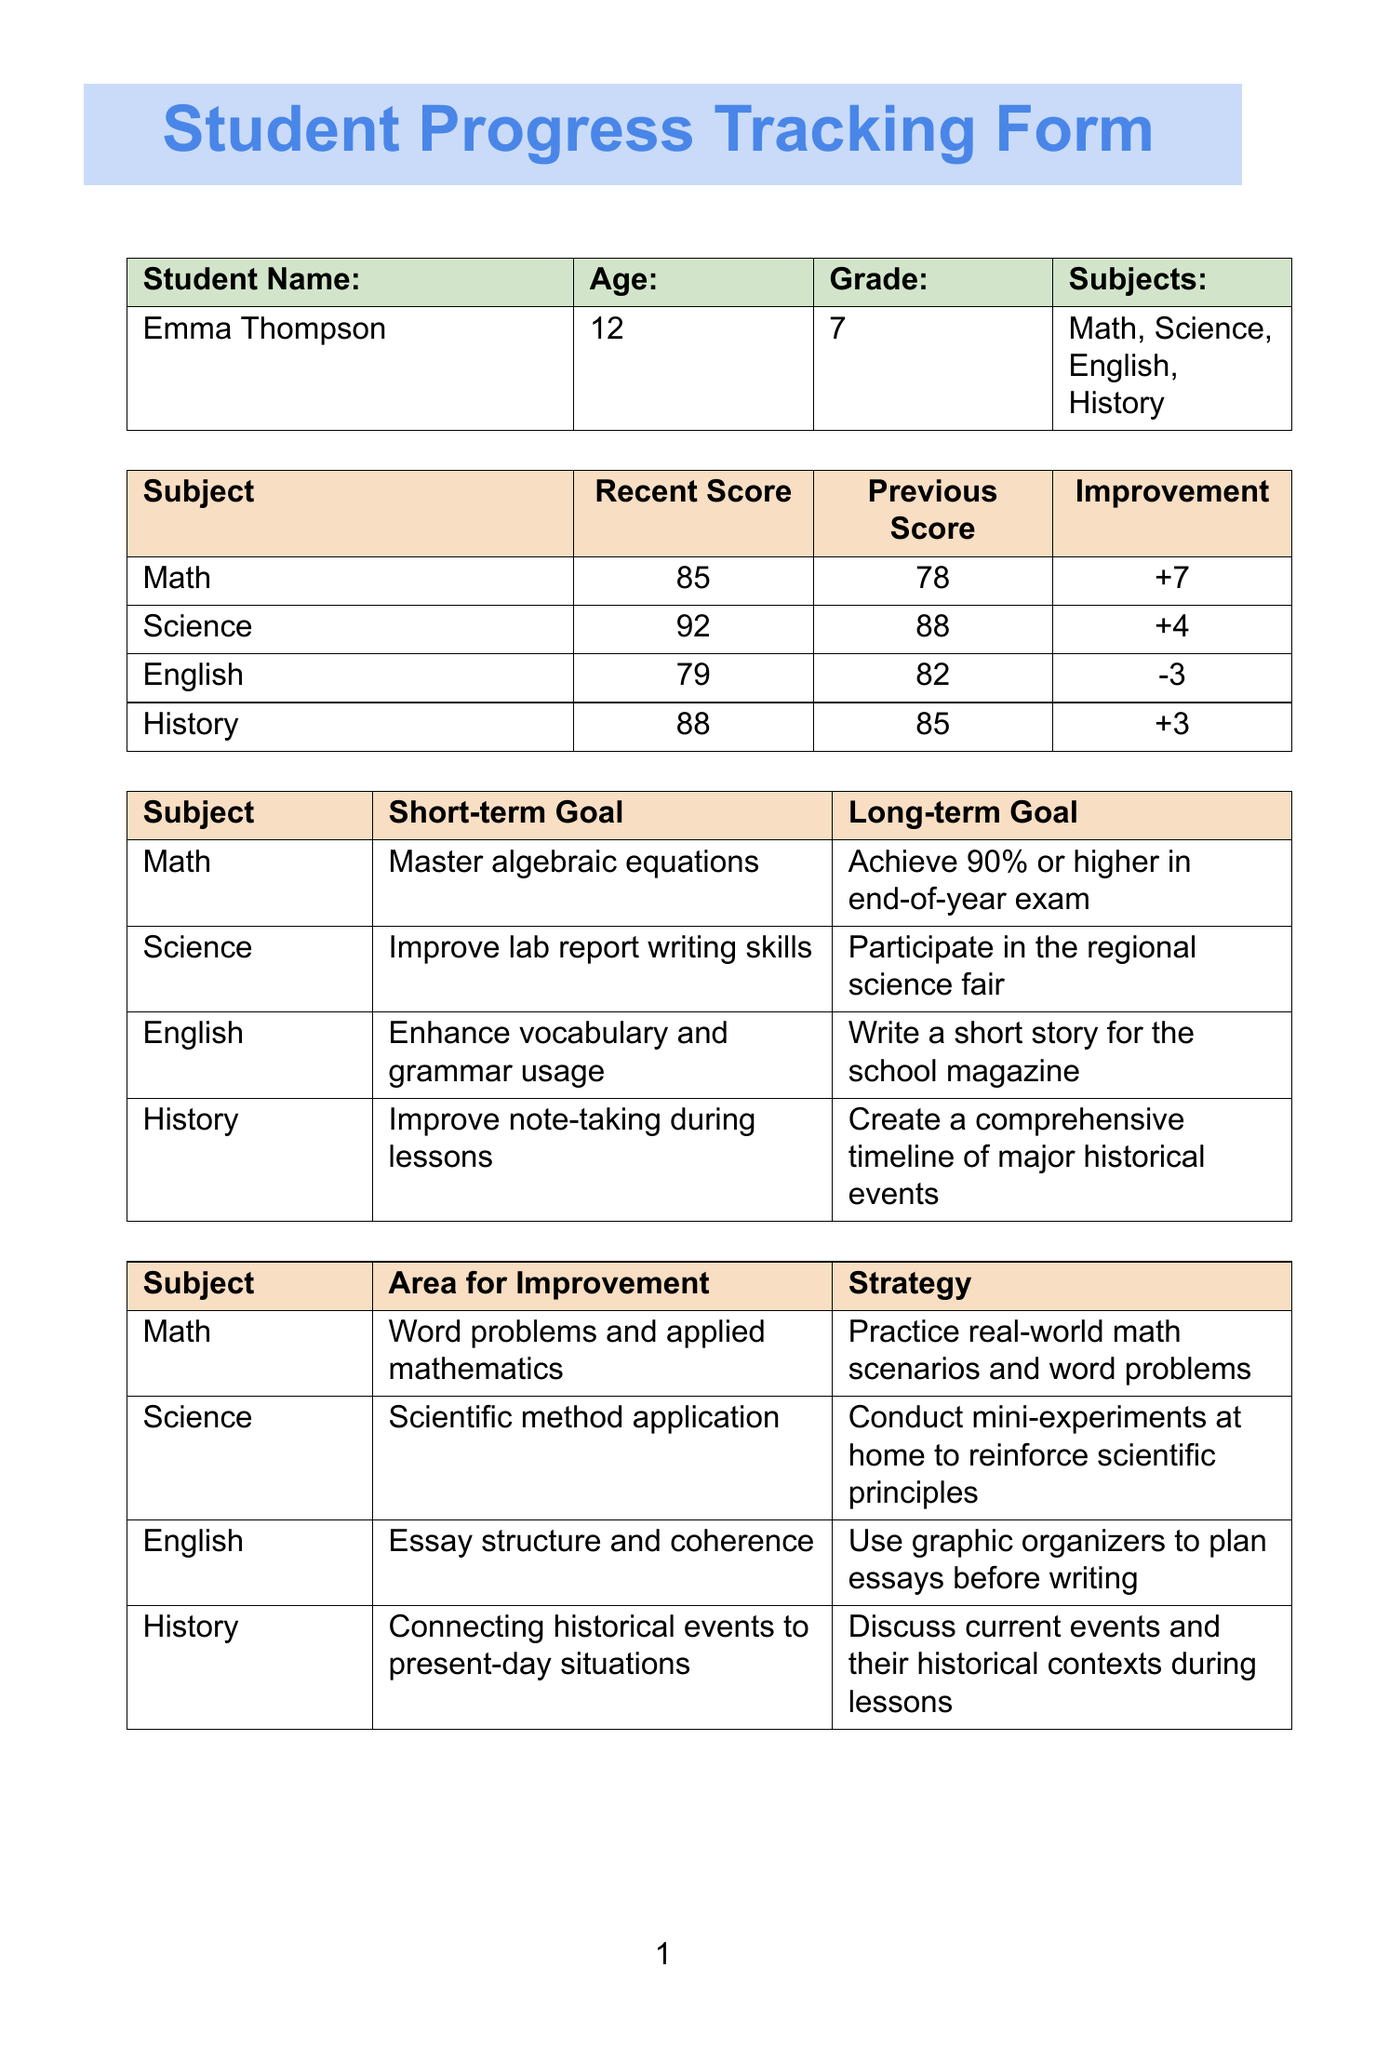What is the student's name? The student's name is found in the student information section of the document.
Answer: Emma Thompson What is Emma's age? The age is specified in the student information section of the document.
Answer: 12 What is Emma's recent score in Science? The recent score for Science is provided in the assessment scores table.
Answer: 92 What is the short-term goal for English? The short-term goal for English is stated in the goals section of the document.
Answer: Enhance vocabulary and grammar usage What area needs improvement in History? The area for improvement in History is listed in the areas for improvement table.
Answer: Connecting historical events to present-day situations What is the date of the mid-term exams? The date for the mid-term exams is mentioned in the upcoming milestones section.
Answer: 2023-10-15 How much has Emma improved in Math? The improvement in Math is calculated from the recent and previous scores in the assessment scores table.
Answer: 7 What resource is provided for Science? The resource for Science can be found in the resources provided section of the document.
Answer: National Geographic Kids Science Lab What is the overall progress noted by the tutor? The overall progress is found in the tutor notes section of the document.
Answer: Emma has shown significant improvement in Math and Science 